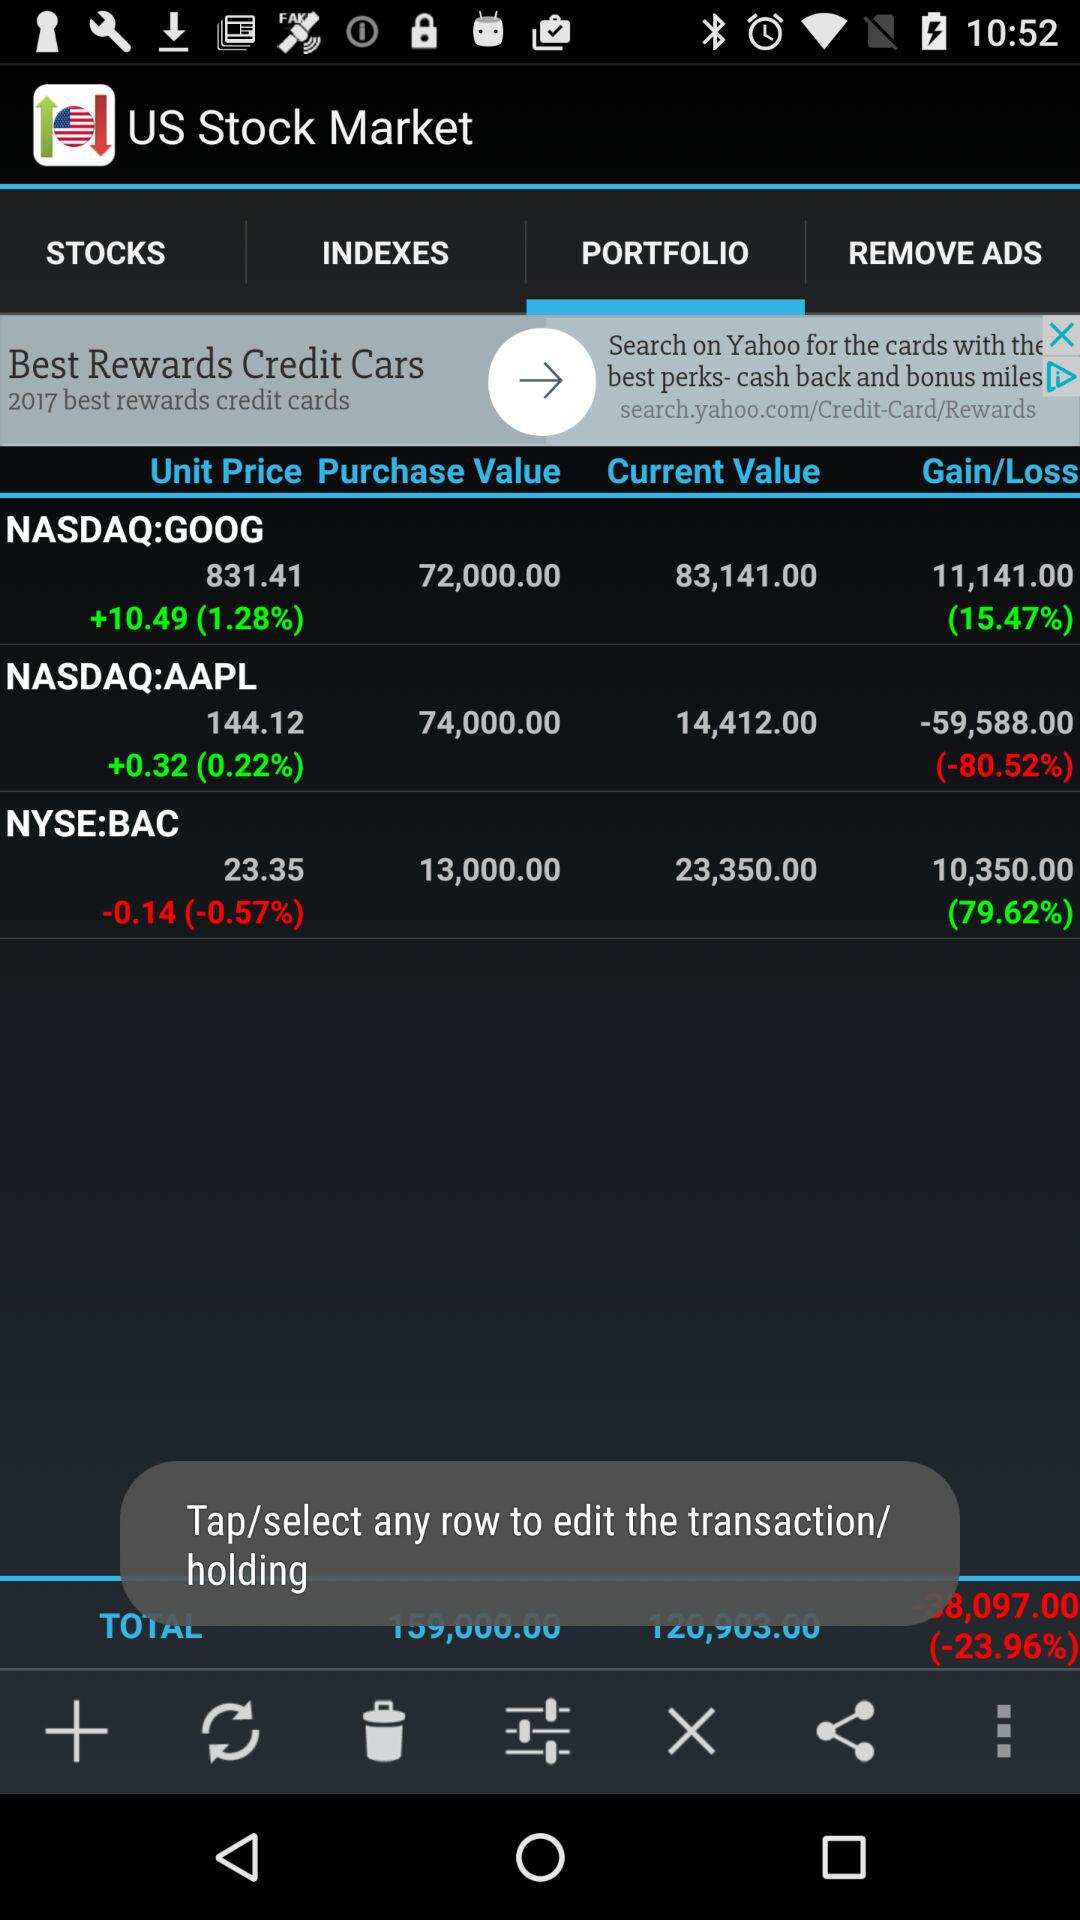What is the current value of NYSE:BAC? The current value of NYSE:BAC is 23,350. 